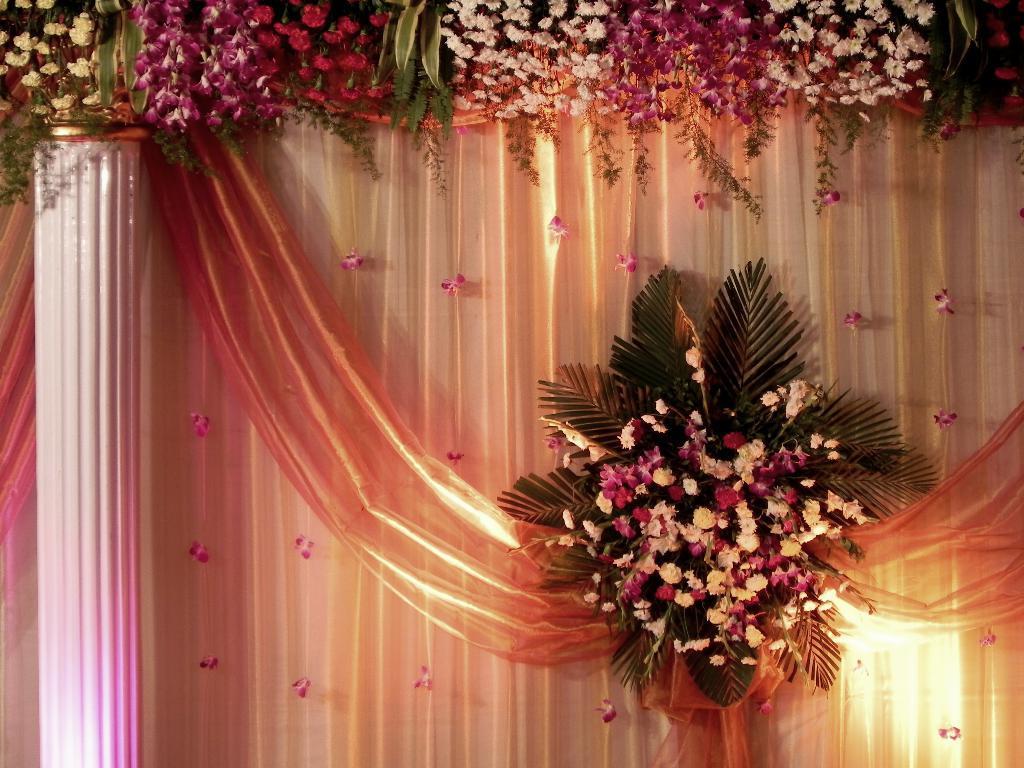Can you describe this image briefly? In this image we can see a bouquet. To the top of the image there are flowers. There is a pillar. In the background of the image there is cloth. 